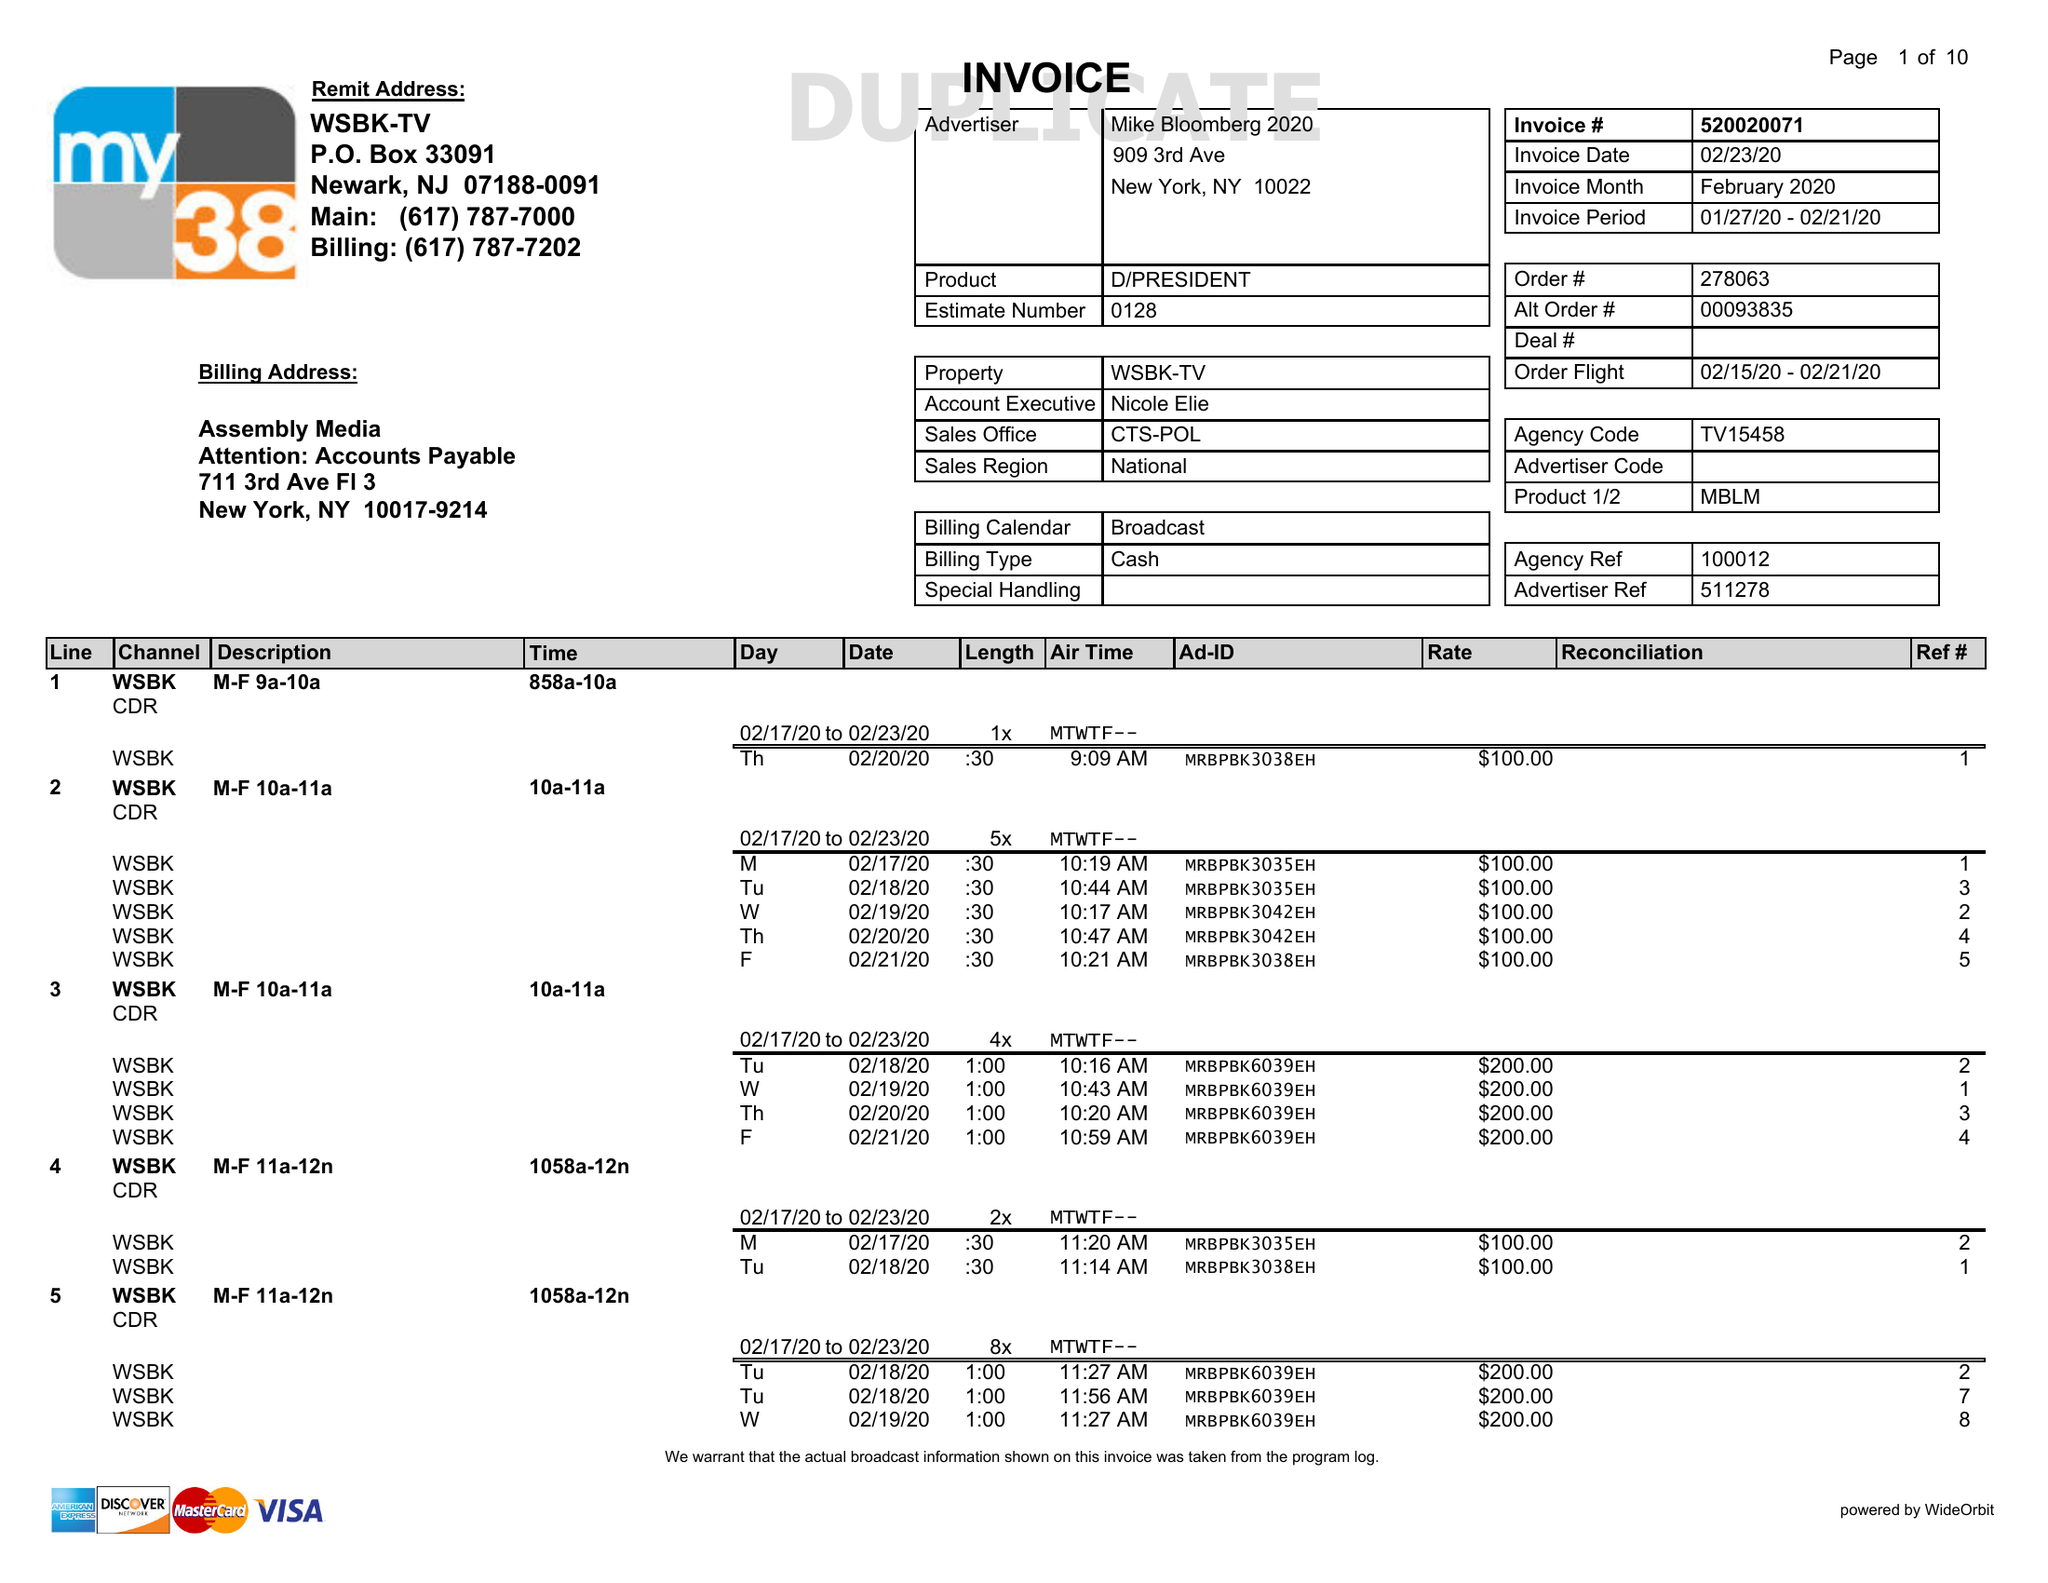What is the value for the flight_from?
Answer the question using a single word or phrase. 02/15/20 